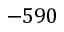<formula> <loc_0><loc_0><loc_500><loc_500>- 5 9 0</formula> 